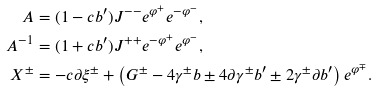Convert formula to latex. <formula><loc_0><loc_0><loc_500><loc_500>A & = ( 1 - c b ^ { \prime } ) J ^ { - - } e ^ { \varphi ^ { + } } e ^ { - \varphi ^ { - } } , \\ A ^ { - 1 } & = ( 1 + c b ^ { \prime } ) J ^ { + + } e ^ { - \varphi ^ { + } } e ^ { \varphi ^ { - } } , \\ X ^ { \pm } & = - c \partial \xi ^ { \pm } + \left ( G ^ { \pm } - 4 \gamma ^ { \pm } b \pm 4 \partial \gamma ^ { \pm } b ^ { \prime } \pm 2 \gamma ^ { \pm } \partial b ^ { \prime } \right ) e ^ { \varphi ^ { \mp } } .</formula> 